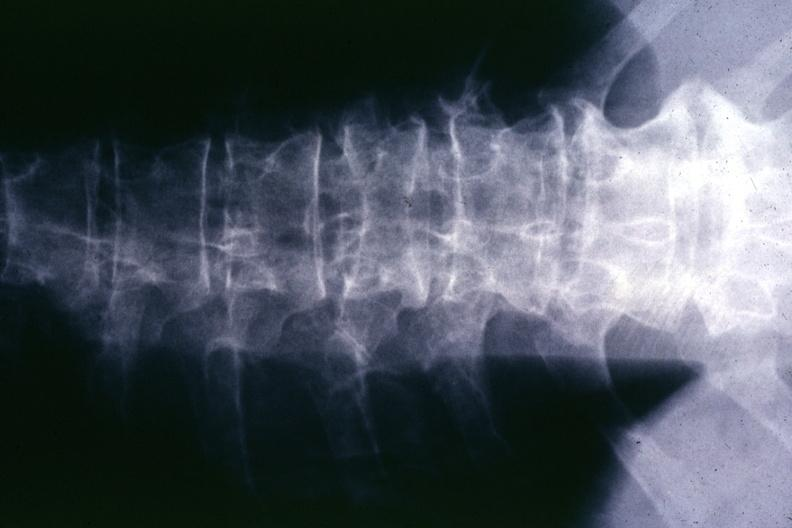does prostate show x-ray multiple punched out areas and compression fracture?
Answer the question using a single word or phrase. No 